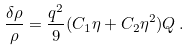<formula> <loc_0><loc_0><loc_500><loc_500>\frac { \delta \rho } { \rho } = \frac { q ^ { 2 } } { 9 } ( C _ { 1 } \eta + C _ { 2 } \eta ^ { 2 } ) Q \, .</formula> 